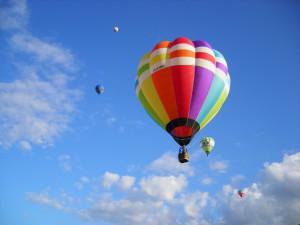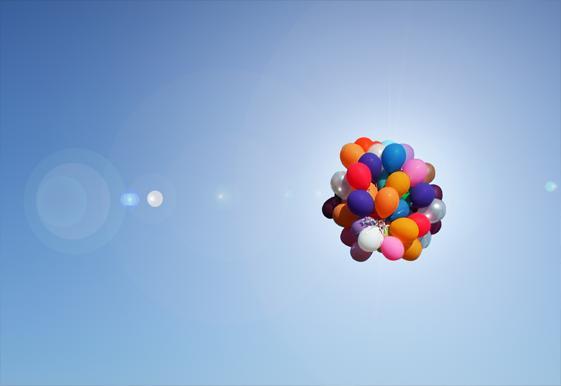The first image is the image on the left, the second image is the image on the right. Assess this claim about the two images: "More than 50 individual loose balloons float up into the sky.". Correct or not? Answer yes or no. No. The first image is the image on the left, the second image is the image on the right. Analyze the images presented: Is the assertion "The left image features a string-tied 'bunch' of no more than ten balloons, and the right image shows balloons scattered across the sky." valid? Answer yes or no. No. 